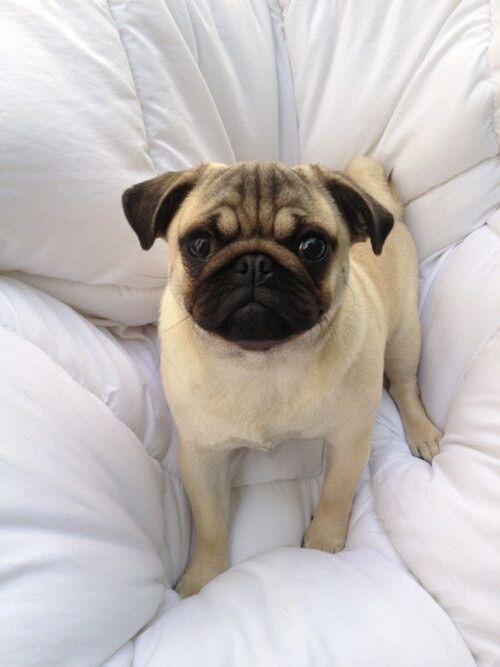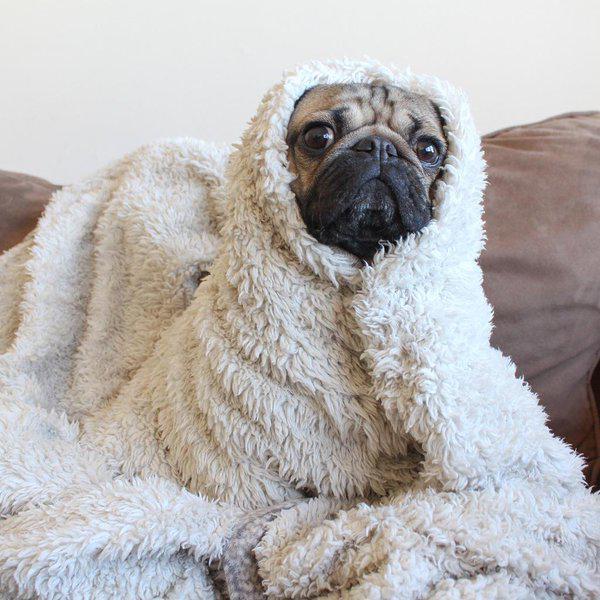The first image is the image on the left, the second image is the image on the right. Given the left and right images, does the statement "A black pug lying with its head sideways is peeking out from under a sheet in the left image." hold true? Answer yes or no. No. The first image is the image on the left, the second image is the image on the right. Given the left and right images, does the statement "In the right image, the pug has no paws sticking out of the blanket." hold true? Answer yes or no. Yes. 